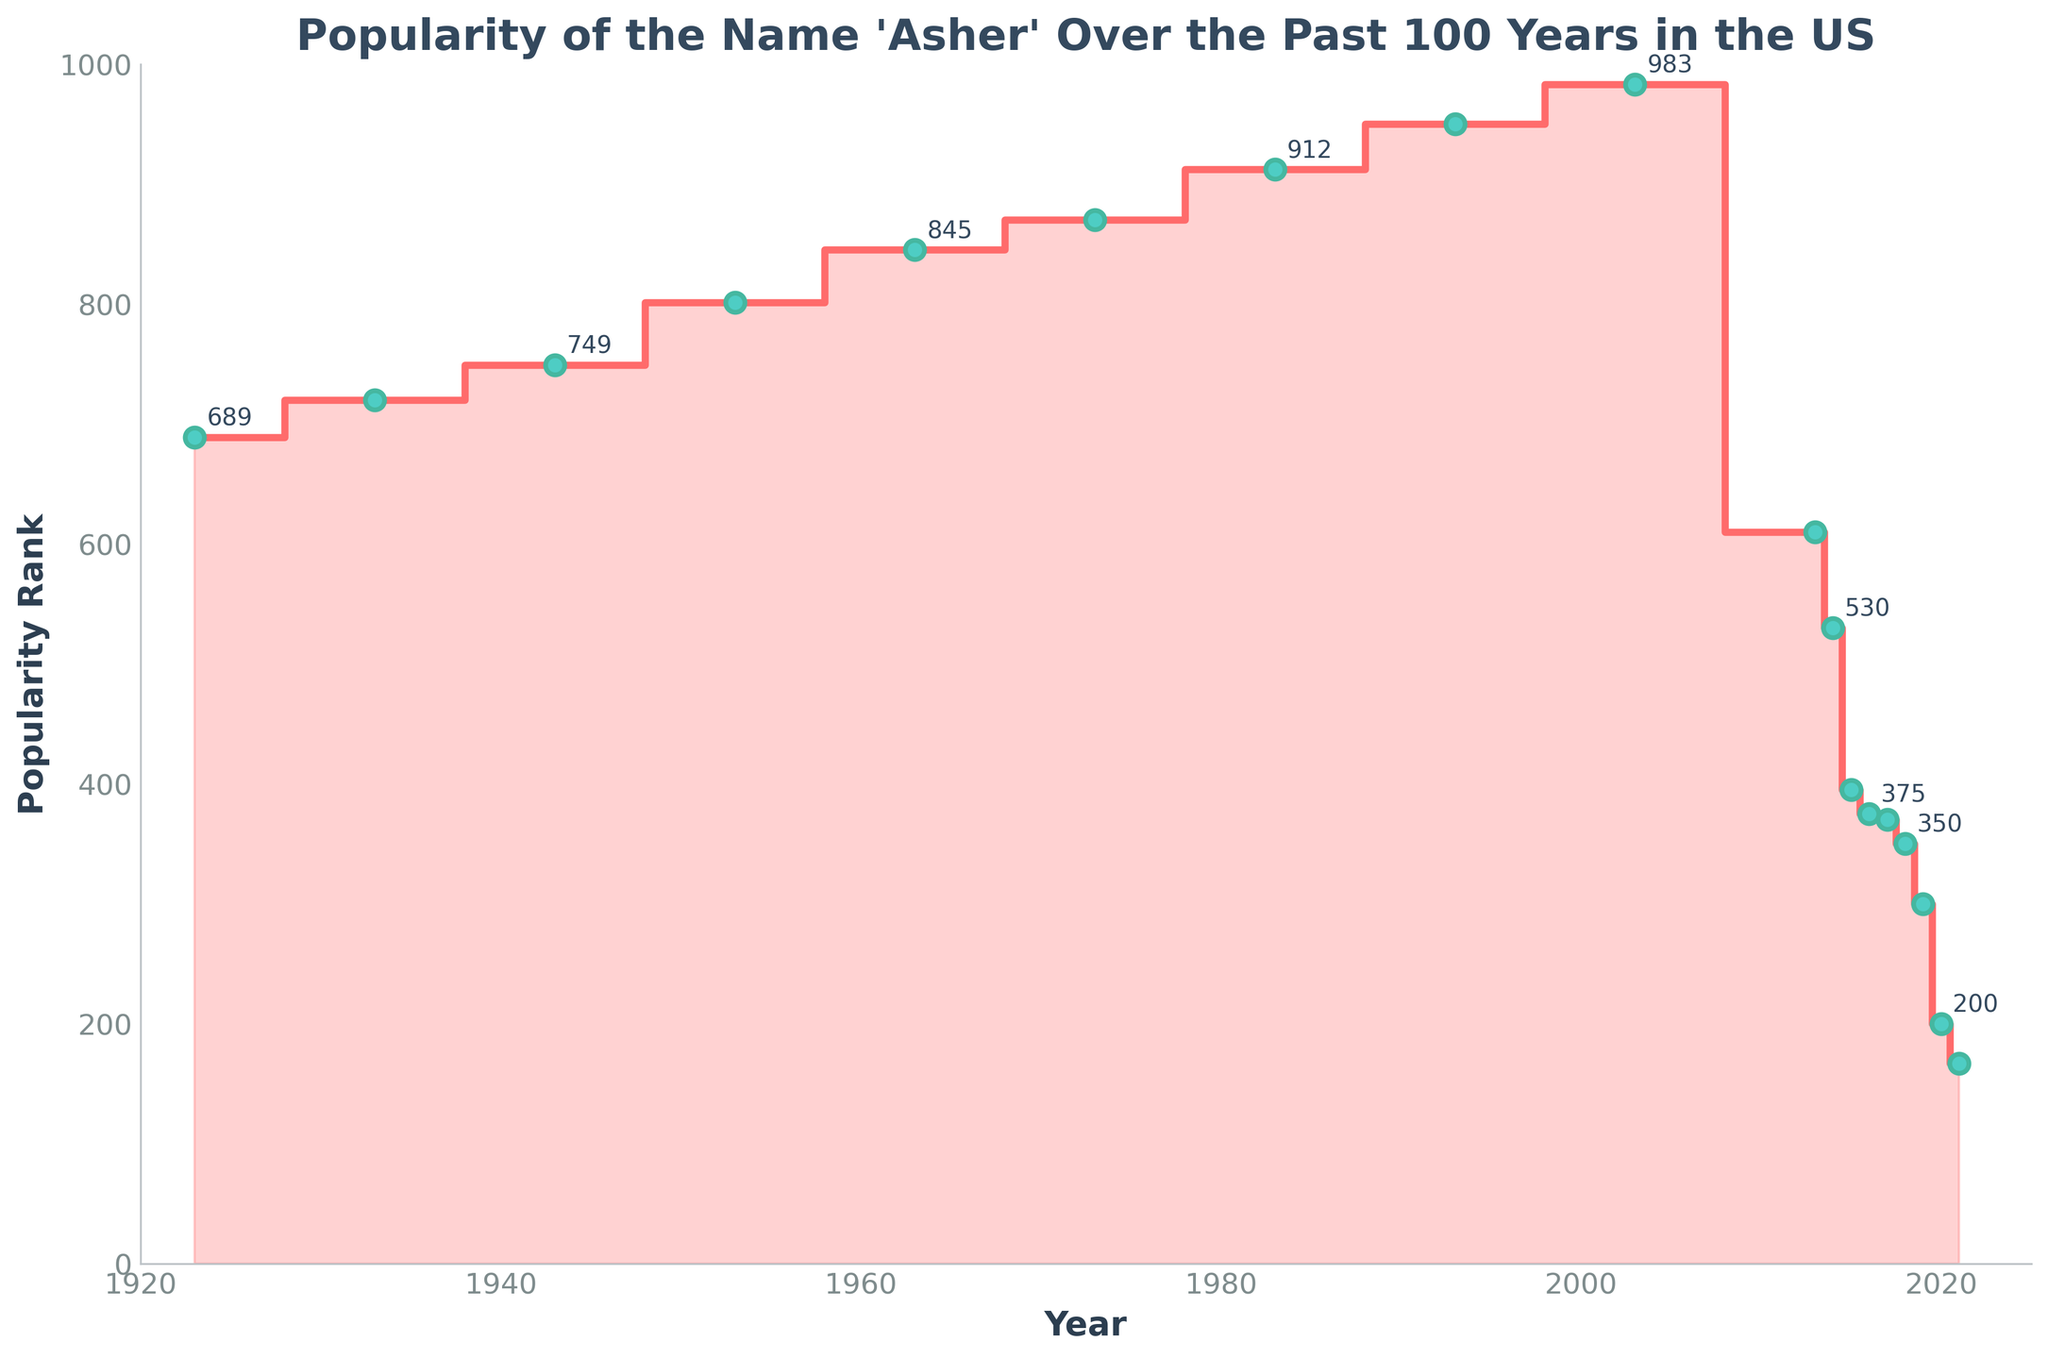What is the title of the plot? The title of the plot is displayed at the top center and provides a quick overview of what the figure is about.
Answer: "Popularity of the Name 'Asher' Over the Past 100 Years in the US" How many data points are shown on the plot? The number of data points can be determined by counting the dots or labels displayed on the curve.
Answer: 18 In which year was the name "Asher" most popular? The most popular year can be identified by noting the lowest rank value in the vertical axis since lower rank means higher popularity.
Answer: 2021 What is the popularity rank of "Asher" in 1953? The popularity rank for a specific year can be found by locating the year on the x-axis and reading the corresponding rank on the y-axis.
Answer: 801 How did the popularity of "Asher" change between 2003 and 2013? To determine the change, compare the ranks in 2003 and 2013, noting whether the rank has decreased or increased.
Answer: Decreased (from 983 to 610) Which period saw the greatest decrease in popularity of the name "Asher"? Identify the years with the largest difference in popularity ranks by comparing the values for successive years.
Answer: 2013 to 2021 Between which successive years did "Asher" show an increase in popularity? Look for points where the popularity rank decreases (because lower ranks indicate higher popularity) between successive years.
Answer: 2013 to 2014 What is the trend of the popularity of the name "Asher" from 2013 to 2021? Evaluate the change in popularity rank over the stated period to see if it is increasing, decreasing, or stable.
Answer: Increasing How much did the popularity rank change from 2019 to 2021? Calculate the difference in popularity ranks between 2019 and 2021.
Answer: 133 (from 300 to 167) 